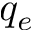<formula> <loc_0><loc_0><loc_500><loc_500>q _ { e }</formula> 